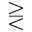Convert formula to latex. <formula><loc_0><loc_0><loc_500><loc_500>> r e q l e s s</formula> 